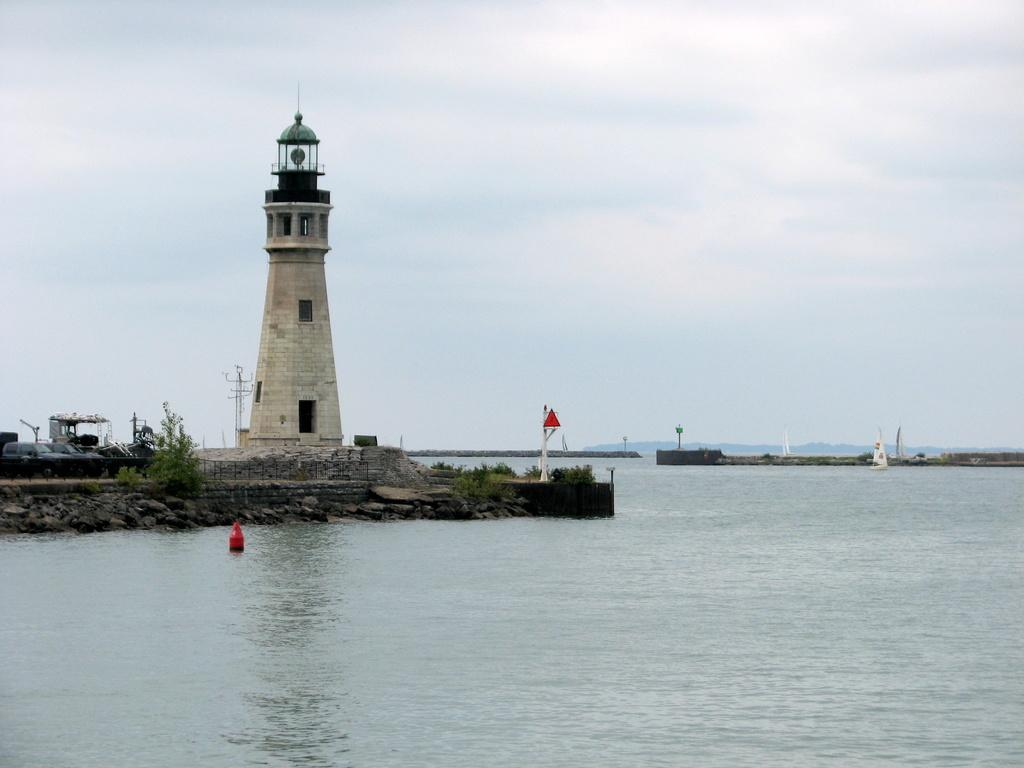What is the main structure in the image? There is a lighthouse in the image. What are the main features of the lighthouse? The lighthouse has walls and pillars. What other objects or elements can be seen in the image? There are plants, poles, water, a boat, and the sky visible in the image. Can you see any pears hanging from the lighthouse in the image? There are no pears present in the image, and they are not hanging from the lighthouse. Is there an airport visible in the image? There is no airport present in the image. 